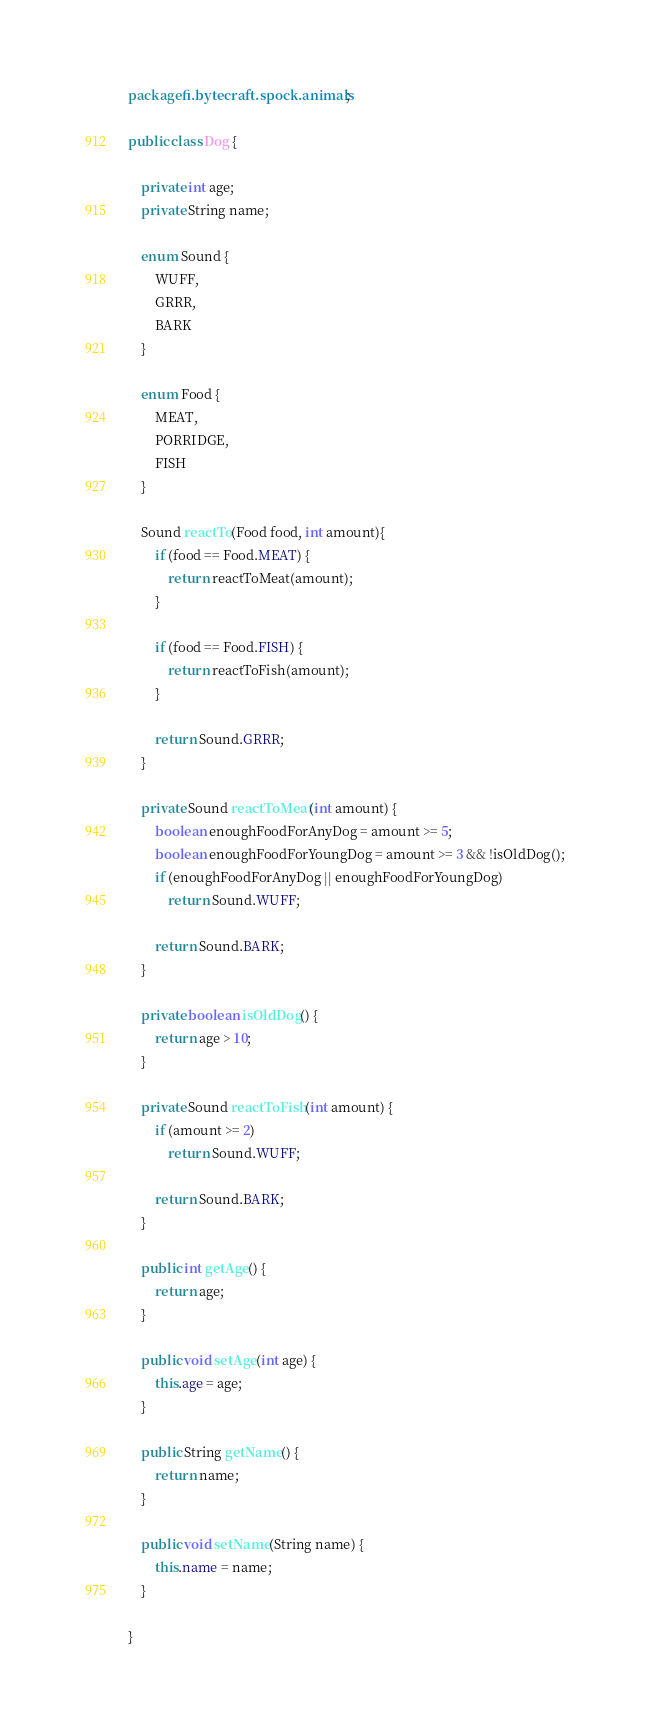Convert code to text. <code><loc_0><loc_0><loc_500><loc_500><_Java_>package fi.bytecraft.spock.animals;

public class Dog {

    private int age;
    private String name;

    enum Sound {
        WUFF,
        GRRR,
        BARK
    }

    enum Food {
        MEAT,
        PORRIDGE,
        FISH
    }

    Sound reactTo(Food food, int amount){
        if (food == Food.MEAT) {
            return reactToMeat(amount);
        }

        if (food == Food.FISH) {
            return reactToFish(amount);
        }

        return Sound.GRRR;
    }

    private Sound reactToMeat(int amount) {
        boolean enoughFoodForAnyDog = amount >= 5;
        boolean enoughFoodForYoungDog = amount >= 3 && !isOldDog();
        if (enoughFoodForAnyDog || enoughFoodForYoungDog)
            return Sound.WUFF;

        return Sound.BARK;
    }

    private boolean isOldDog() {
        return age > 10;
    }

    private Sound reactToFish(int amount) {
        if (amount >= 2)
            return Sound.WUFF;

        return Sound.BARK;
    }

    public int getAge() {
        return age;
    }

    public void setAge(int age) {
        this.age = age;
    }

    public String getName() {
        return name;
    }

    public void setName(String name) {
        this.name = name;
    }

}
</code> 